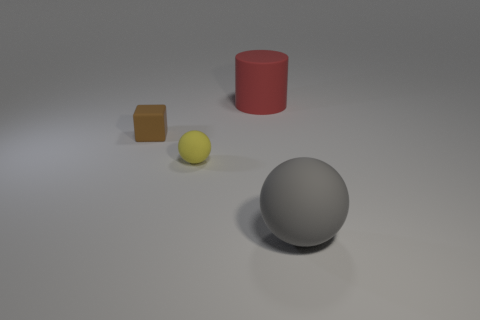Add 1 tiny yellow matte objects. How many objects exist? 5 Subtract all cylinders. How many objects are left? 3 Add 4 brown matte blocks. How many brown matte blocks are left? 5 Add 4 tiny brown cylinders. How many tiny brown cylinders exist? 4 Subtract 0 yellow blocks. How many objects are left? 4 Subtract all tiny matte things. Subtract all red cylinders. How many objects are left? 1 